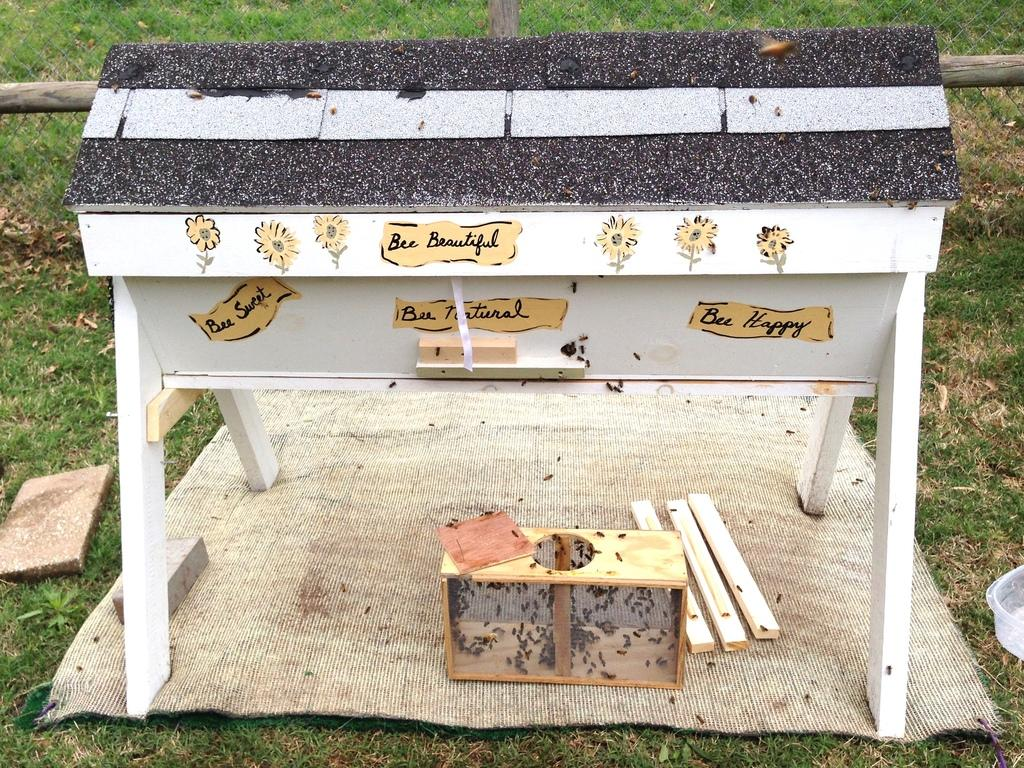<image>
Describe the image concisely. Handmade beehive with stickers stating Bee Happy, Bee Beautiful, Bee Natural, and Bee Sweet stuck on the front. 